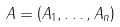Convert formula to latex. <formula><loc_0><loc_0><loc_500><loc_500>A = \left ( A _ { 1 } , \dots , A _ { n } \right )</formula> 